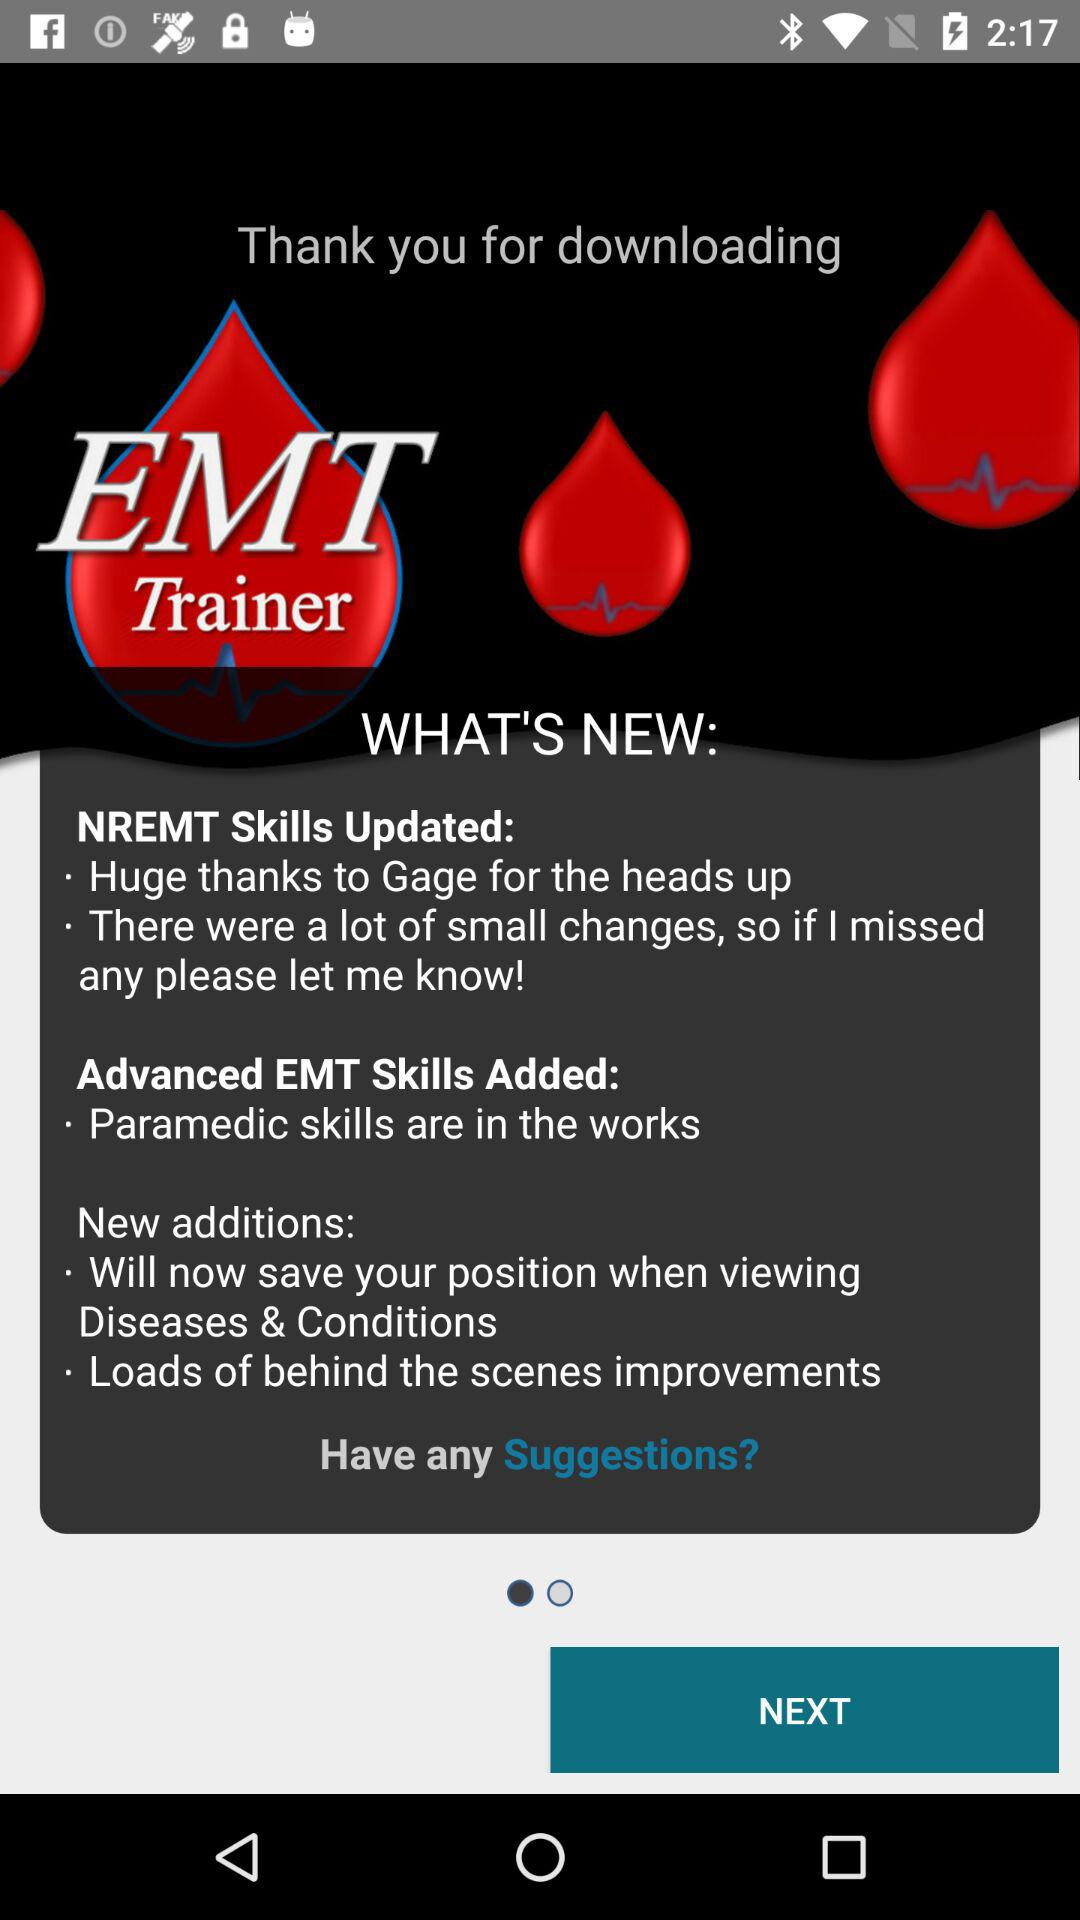What are the new advanced EMT skills? The new advanced EMT skill is "Paramedic skills are in the works". 